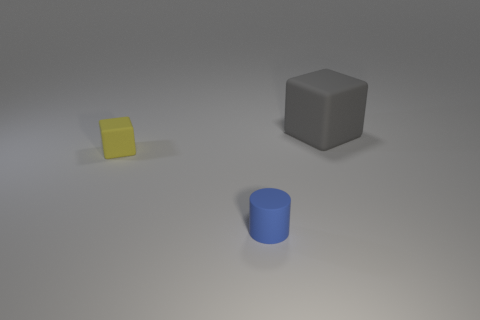Subtract all cylinders. How many objects are left? 2 Add 3 large brown metallic things. How many objects exist? 6 Subtract 1 blocks. How many blocks are left? 1 Subtract all gray blocks. Subtract all red balls. How many blocks are left? 1 Subtract all brown balls. How many yellow blocks are left? 1 Subtract all rubber cylinders. Subtract all large gray matte things. How many objects are left? 1 Add 1 tiny matte things. How many tiny matte things are left? 3 Add 1 blue cylinders. How many blue cylinders exist? 2 Subtract 0 purple cylinders. How many objects are left? 3 